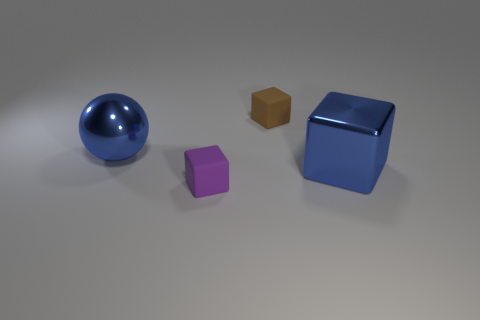What number of cubes are both on the left side of the large blue block and behind the small purple rubber block?
Give a very brief answer. 1. Is there another tiny object made of the same material as the small purple object?
Give a very brief answer. Yes. What is the material of the big object to the right of the big blue object that is behind the big blue cube?
Keep it short and to the point. Metal. Are there the same number of large blue shiny things that are to the left of the brown matte thing and big shiny cubes to the right of the small purple cube?
Ensure brevity in your answer.  Yes. Do the purple object and the small brown thing have the same shape?
Your response must be concise. Yes. What material is the cube that is behind the purple cube and on the left side of the blue shiny block?
Your answer should be compact. Rubber. How many large metallic things are the same shape as the brown matte thing?
Ensure brevity in your answer.  1. What is the size of the matte block that is in front of the tiny matte cube that is behind the big block that is right of the blue sphere?
Provide a succinct answer. Small. Is the number of big metallic things that are in front of the blue block greater than the number of small purple objects?
Offer a very short reply. No. Are there any green cubes?
Give a very brief answer. No. 